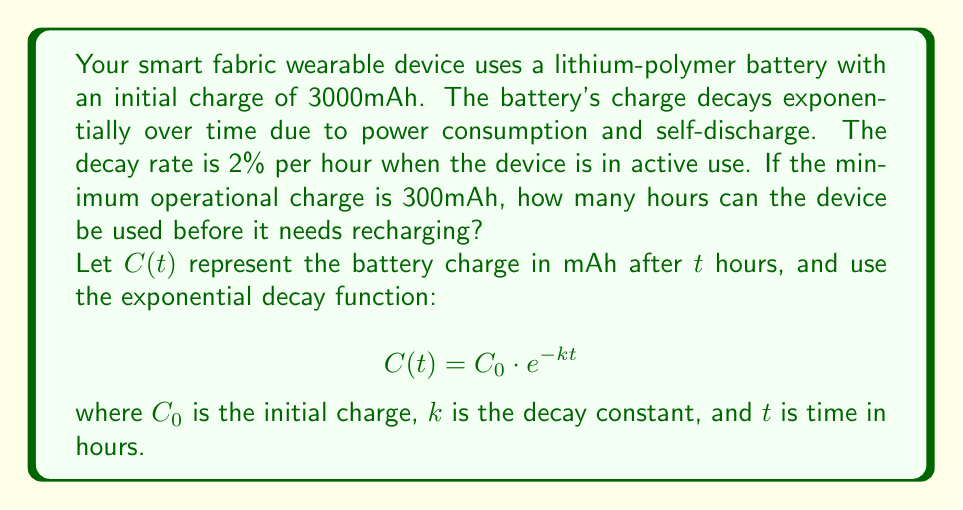Provide a solution to this math problem. To solve this problem, we'll follow these steps:

1. Determine the decay constant $k$:
   The decay rate is 2% per hour, so $k = -\ln(1 - 0.02) \approx 0.0202$

2. Set up the exponential decay equation:
   $$C(t) = 3000 \cdot e^{-0.0202t}$$

3. Set $C(t)$ equal to the minimum operational charge and solve for $t$:
   $$300 = 3000 \cdot e^{-0.0202t}$$

4. Divide both sides by 3000:
   $$0.1 = e^{-0.0202t}$$

5. Take the natural logarithm of both sides:
   $$\ln(0.1) = -0.0202t$$

6. Solve for $t$:
   $$t = \frac{\ln(0.1)}{-0.0202} \approx 113.77$$

Therefore, the device can be used for approximately 113.77 hours before needing to be recharged.
Answer: 113.77 hours 